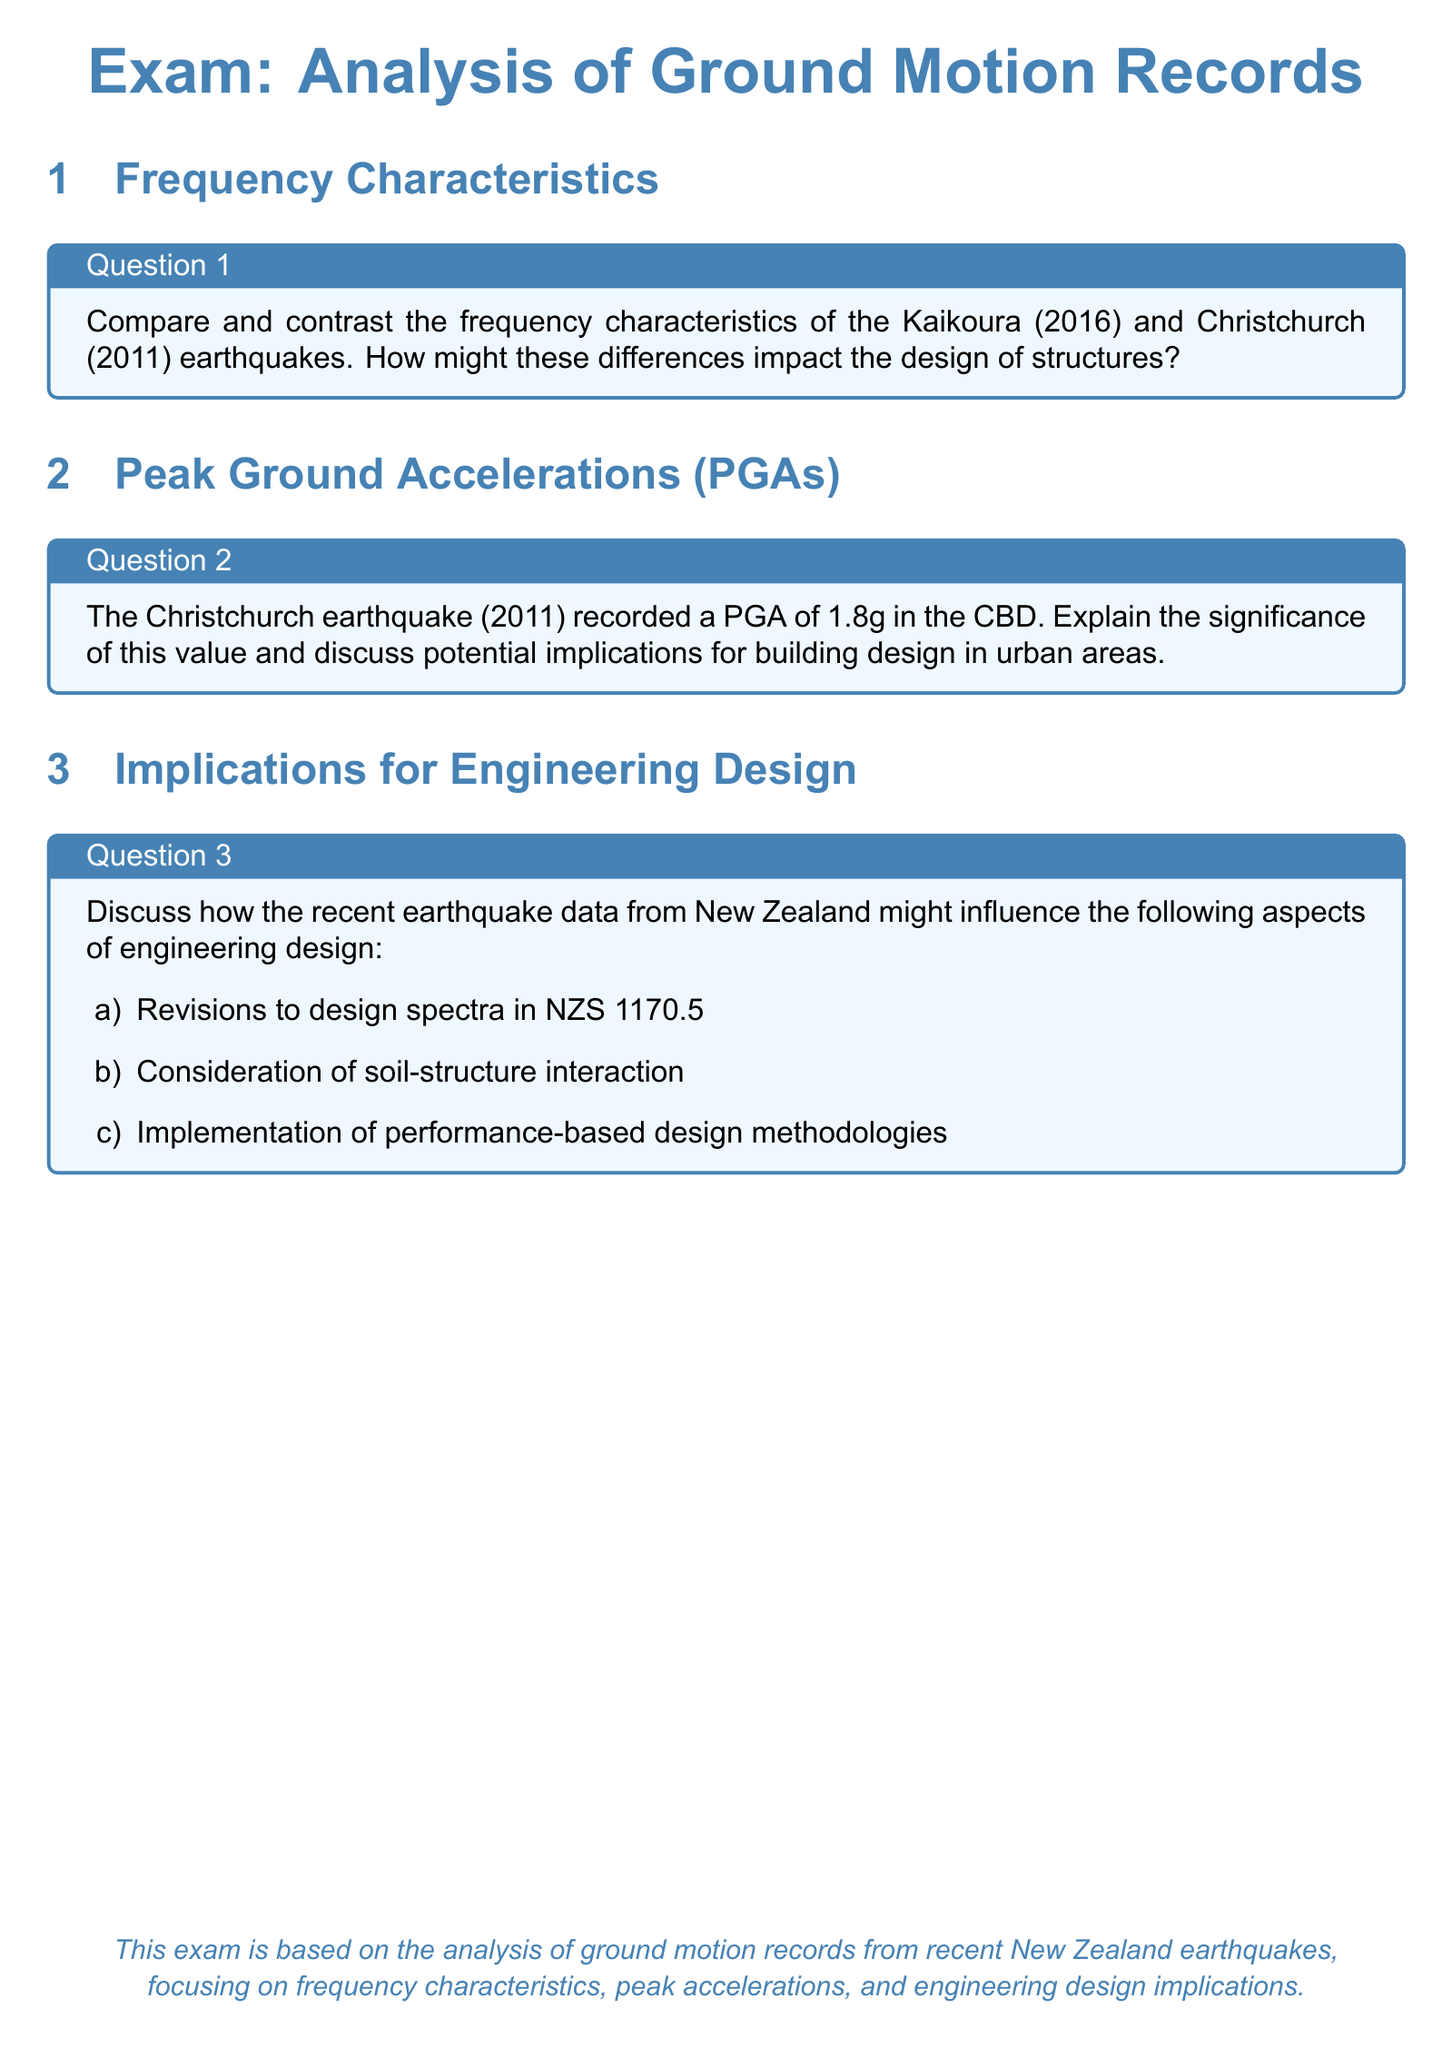What is the title of the exam? The title of the exam as indicated in the document is "Exam: Analysis of Ground Motion Records."
Answer: Analysis of Ground Motion Records Which earthquake recorded a PGA of 1.8g? The document states that the Christchurch earthquake (2011) recorded a PGA of 1.8g in the CBD.
Answer: Christchurch earthquake (2011) List one aspect of engineering design influenced by New Zealand earthquake data mentioned in the document. The document mentions aspects such as revisions to design spectra in NZS 1170.5, soil-structure interaction, and performance-based design methodologies.
Answer: Revisions to design spectra in NZS 1170.5 What year did the Kaikoura earthquake occur? The document mentions the Kaikoura earthquake occurred in 2016.
Answer: 2016 In what section can you find Question 3? Question 3 is found in the section titled "Implications for Engineering Design."
Answer: Implications for Engineering Design 